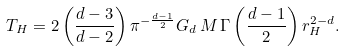<formula> <loc_0><loc_0><loc_500><loc_500>T _ { H } = 2 \left ( \frac { d - 3 } { d - 2 } \right ) \pi ^ { - \frac { d - 1 } { 2 } } G _ { d } \, M \, \Gamma \left ( \frac { d - 1 } { 2 } \right ) r _ { H } ^ { 2 - d } .</formula> 